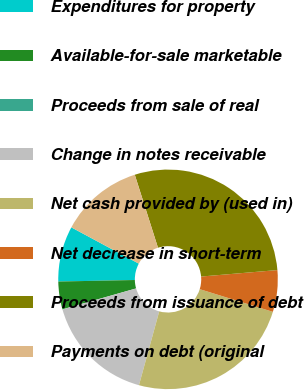<chart> <loc_0><loc_0><loc_500><loc_500><pie_chart><fcel>Expenditures for property<fcel>Available-for-sale marketable<fcel>Proceeds from sale of real<fcel>Change in notes receivable<fcel>Net cash provided by (used in)<fcel>Net decrease in short-term<fcel>Proceeds from issuance of debt<fcel>Payments on debt (original<nl><fcel>8.17%<fcel>4.09%<fcel>0.01%<fcel>16.32%<fcel>24.48%<fcel>6.13%<fcel>28.55%<fcel>12.25%<nl></chart> 